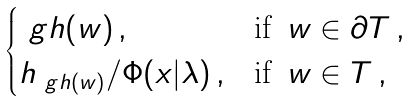<formula> <loc_0><loc_0><loc_500><loc_500>\begin{cases} \ g h ( w ) \, , & \text {if } \, w \in \partial T \, , \\ h _ { \ g h ( w ) } / \Phi ( x | \lambda ) \, , & \text {if } \, w \in T \, , \end{cases}</formula> 